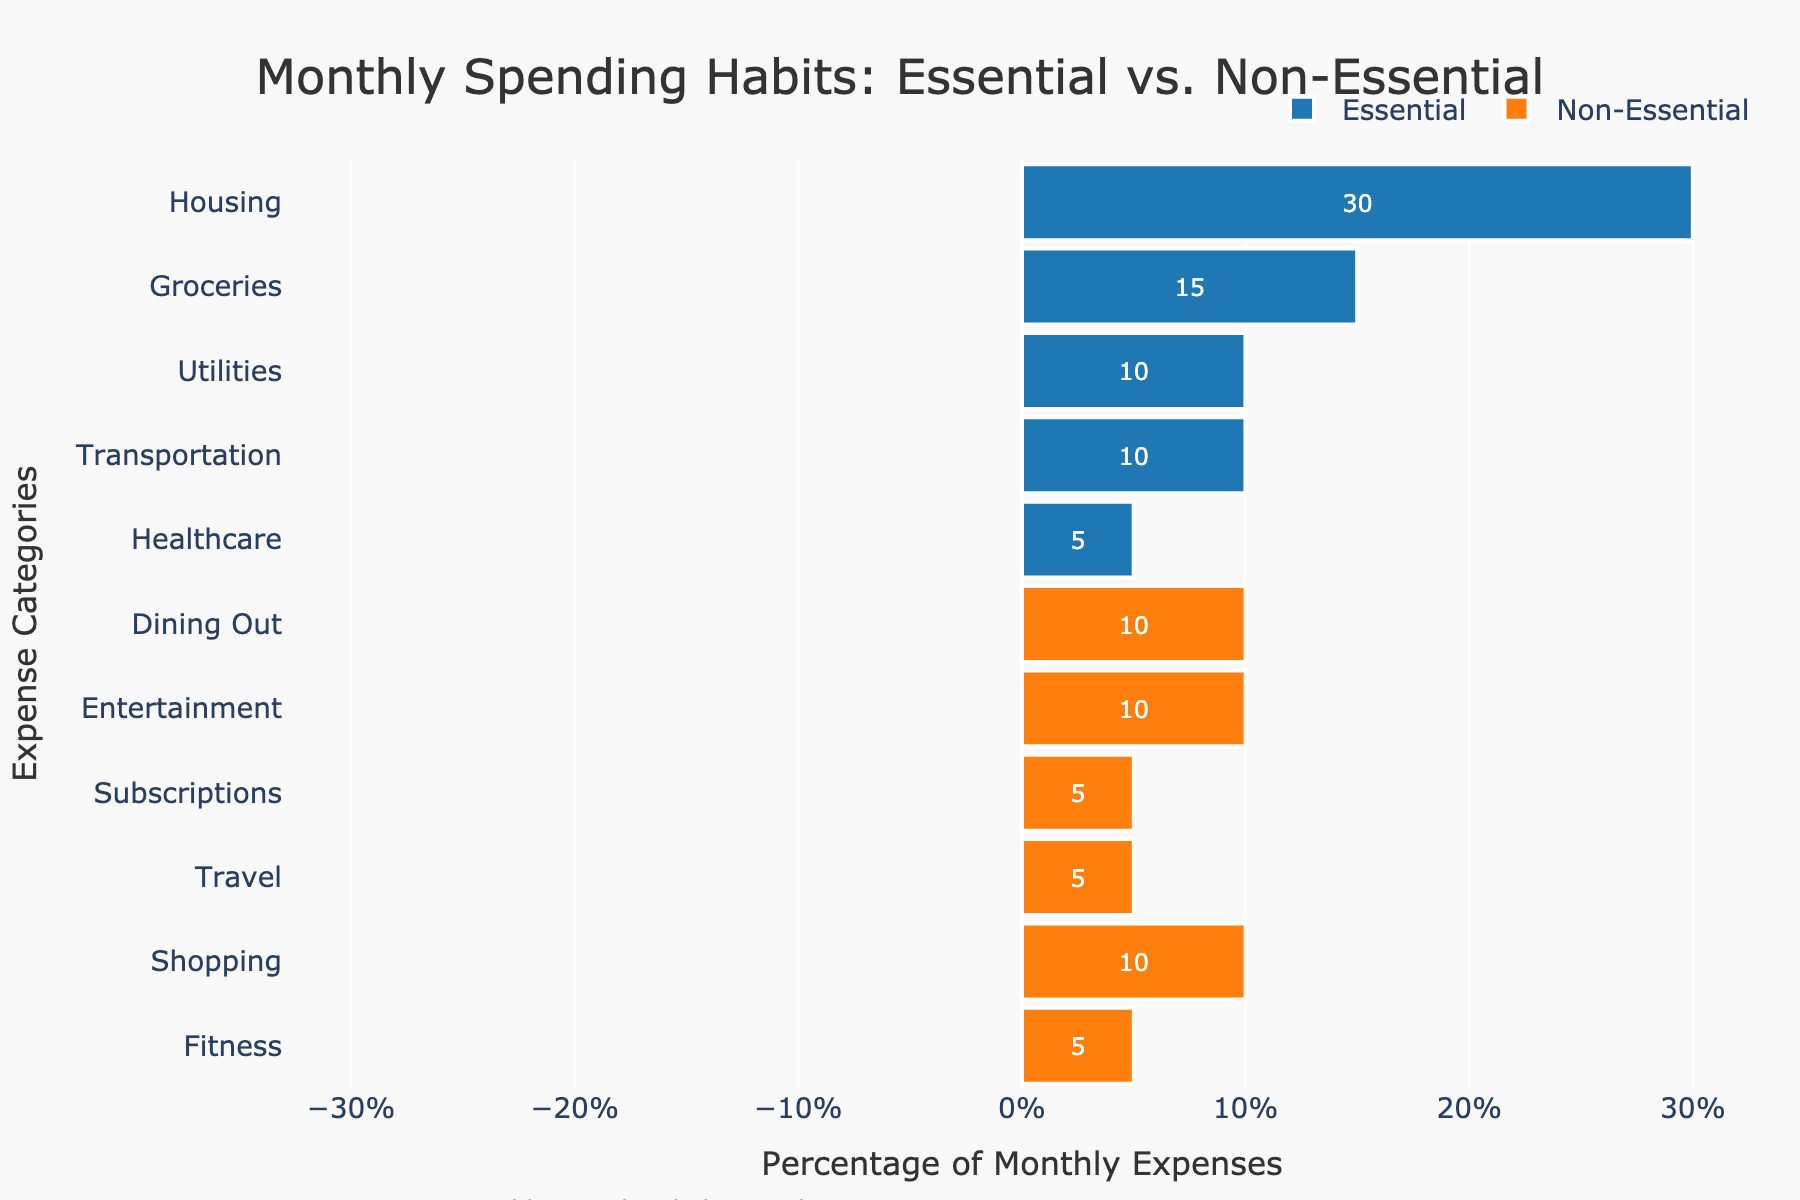What's the total percentage spent on Essential expenses? Sum the percentages of all Essential expenses: 30 (Housing) + 15 (Groceries) + 10 (Utilities) + 10 (Transportation) + 5 (Healthcare). That equals 70%.
Answer: 70% Which expense category has the highest percentage of Non-Essential expenses? The highest non-essential percentages are in Dining Out, Entertainment, and Shopping, each with 10%.
Answer: Dining Out, Entertainment, Shopping What proportion of the total is spent on Entertainment and Shopping combined? Add the percentages of Entertainment and Shopping: 10 (Entertainment) + 10 (Shopping) = 20%.
Answer: 20% Which categories do not have any Non-Essential expenses? Look for categories with 0% in Non-Essential expenses: Housing, Groceries, Utilities, Transportation, and Healthcare.
Answer: Housing, Groceries, Utilities, Transportation, Healthcare What percentage is spent on Transportation compared to Travel? Transportation (10%) is 2 times greater than Travel (5%).
Answer: 2 times How does the percentage for Healthcare (an Essential expense) compare to Subscriptions (a Non-Essential expense)? Healthcare is 5%, and Subscriptions are also 5%. They are the same.
Answer: Same What is the difference in percentage between the highest Essential and the highest Non-Essential expense category? Highest Essential (Housing, 30%) - Highest Non-Essential (Dining Out/Entertainment/Shopping, 10%): 30% - 10% = 20%.
Answer: 20% Which visual element has the shortest bar? The shortest bars are for Healthcare, Subscriptions, Travel, and Fitness, each at 5%.
Answer: Healthcare, Subscriptions, Travel, Fitness Does any category have an equal percentage of Essential and Non-Essential expenses? None of the categories have equal proportions; they are either 100% Essential or 100% Non-Essential.
Answer: No If you were to remove the category with the lowest Non-Essential spending, what would be the new total percentage of Non-Essential expenses? Remove the lowest Non-Essential category (Subscriptions, 5%), and sum the remaining Non-Essential percentages: 10 (Dining Out) + 10 (Entertainment) + 10 (Shopping) + 5 (Travel) + 5 (Fitness) = 40%.
Answer: 40% 